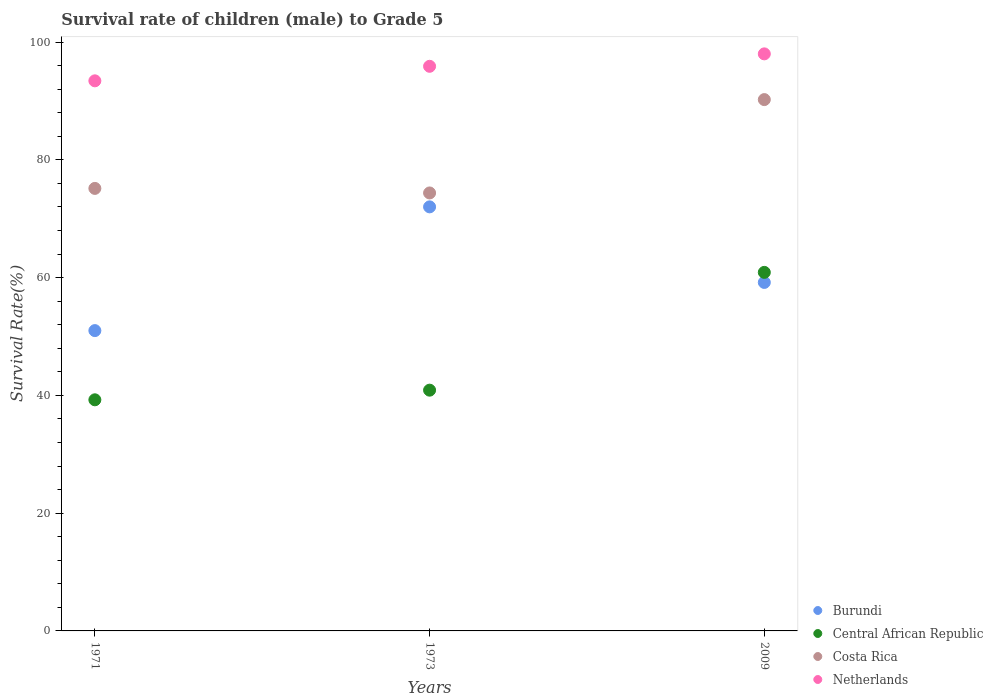How many different coloured dotlines are there?
Offer a very short reply. 4. Is the number of dotlines equal to the number of legend labels?
Offer a terse response. Yes. What is the survival rate of male children to grade 5 in Costa Rica in 1971?
Keep it short and to the point. 75.16. Across all years, what is the maximum survival rate of male children to grade 5 in Central African Republic?
Offer a very short reply. 60.9. Across all years, what is the minimum survival rate of male children to grade 5 in Central African Republic?
Ensure brevity in your answer.  39.25. In which year was the survival rate of male children to grade 5 in Central African Republic maximum?
Provide a short and direct response. 2009. In which year was the survival rate of male children to grade 5 in Central African Republic minimum?
Provide a succinct answer. 1971. What is the total survival rate of male children to grade 5 in Costa Rica in the graph?
Give a very brief answer. 239.78. What is the difference between the survival rate of male children to grade 5 in Costa Rica in 1971 and that in 1973?
Make the answer very short. 0.77. What is the difference between the survival rate of male children to grade 5 in Netherlands in 1971 and the survival rate of male children to grade 5 in Burundi in 2009?
Your response must be concise. 34.24. What is the average survival rate of male children to grade 5 in Netherlands per year?
Your response must be concise. 95.78. In the year 1973, what is the difference between the survival rate of male children to grade 5 in Netherlands and survival rate of male children to grade 5 in Costa Rica?
Offer a terse response. 21.51. What is the ratio of the survival rate of male children to grade 5 in Burundi in 1971 to that in 1973?
Provide a short and direct response. 0.71. Is the survival rate of male children to grade 5 in Costa Rica in 1973 less than that in 2009?
Your answer should be compact. Yes. Is the difference between the survival rate of male children to grade 5 in Netherlands in 1971 and 1973 greater than the difference between the survival rate of male children to grade 5 in Costa Rica in 1971 and 1973?
Provide a short and direct response. No. What is the difference between the highest and the second highest survival rate of male children to grade 5 in Costa Rica?
Provide a short and direct response. 15.08. What is the difference between the highest and the lowest survival rate of male children to grade 5 in Burundi?
Provide a succinct answer. 21.02. In how many years, is the survival rate of male children to grade 5 in Burundi greater than the average survival rate of male children to grade 5 in Burundi taken over all years?
Keep it short and to the point. 1. Is the sum of the survival rate of male children to grade 5 in Netherlands in 1971 and 2009 greater than the maximum survival rate of male children to grade 5 in Central African Republic across all years?
Offer a terse response. Yes. Does the survival rate of male children to grade 5 in Burundi monotonically increase over the years?
Give a very brief answer. No. Is the survival rate of male children to grade 5 in Burundi strictly greater than the survival rate of male children to grade 5 in Netherlands over the years?
Ensure brevity in your answer.  No. How many dotlines are there?
Offer a terse response. 4. What is the difference between two consecutive major ticks on the Y-axis?
Keep it short and to the point. 20. Does the graph contain any zero values?
Offer a very short reply. No. Where does the legend appear in the graph?
Offer a very short reply. Bottom right. How many legend labels are there?
Ensure brevity in your answer.  4. What is the title of the graph?
Your answer should be compact. Survival rate of children (male) to Grade 5. What is the label or title of the Y-axis?
Your answer should be very brief. Survival Rate(%). What is the Survival Rate(%) of Burundi in 1971?
Offer a terse response. 51.01. What is the Survival Rate(%) of Central African Republic in 1971?
Offer a terse response. 39.25. What is the Survival Rate(%) in Costa Rica in 1971?
Give a very brief answer. 75.16. What is the Survival Rate(%) in Netherlands in 1971?
Provide a short and direct response. 93.43. What is the Survival Rate(%) of Burundi in 1973?
Ensure brevity in your answer.  72.02. What is the Survival Rate(%) in Central African Republic in 1973?
Your answer should be compact. 40.89. What is the Survival Rate(%) in Costa Rica in 1973?
Your answer should be compact. 74.39. What is the Survival Rate(%) of Netherlands in 1973?
Your answer should be very brief. 95.9. What is the Survival Rate(%) of Burundi in 2009?
Offer a very short reply. 59.19. What is the Survival Rate(%) in Central African Republic in 2009?
Your response must be concise. 60.9. What is the Survival Rate(%) in Costa Rica in 2009?
Keep it short and to the point. 90.24. What is the Survival Rate(%) of Netherlands in 2009?
Your answer should be compact. 98.01. Across all years, what is the maximum Survival Rate(%) of Burundi?
Make the answer very short. 72.02. Across all years, what is the maximum Survival Rate(%) in Central African Republic?
Your response must be concise. 60.9. Across all years, what is the maximum Survival Rate(%) in Costa Rica?
Provide a short and direct response. 90.24. Across all years, what is the maximum Survival Rate(%) of Netherlands?
Offer a terse response. 98.01. Across all years, what is the minimum Survival Rate(%) in Burundi?
Your answer should be very brief. 51.01. Across all years, what is the minimum Survival Rate(%) in Central African Republic?
Offer a very short reply. 39.25. Across all years, what is the minimum Survival Rate(%) in Costa Rica?
Give a very brief answer. 74.39. Across all years, what is the minimum Survival Rate(%) in Netherlands?
Offer a terse response. 93.43. What is the total Survival Rate(%) in Burundi in the graph?
Offer a very short reply. 182.22. What is the total Survival Rate(%) of Central African Republic in the graph?
Offer a very short reply. 141.04. What is the total Survival Rate(%) in Costa Rica in the graph?
Your response must be concise. 239.78. What is the total Survival Rate(%) in Netherlands in the graph?
Your response must be concise. 287.33. What is the difference between the Survival Rate(%) of Burundi in 1971 and that in 1973?
Keep it short and to the point. -21.02. What is the difference between the Survival Rate(%) of Central African Republic in 1971 and that in 1973?
Provide a short and direct response. -1.64. What is the difference between the Survival Rate(%) of Costa Rica in 1971 and that in 1973?
Your response must be concise. 0.77. What is the difference between the Survival Rate(%) in Netherlands in 1971 and that in 1973?
Ensure brevity in your answer.  -2.47. What is the difference between the Survival Rate(%) of Burundi in 1971 and that in 2009?
Provide a short and direct response. -8.18. What is the difference between the Survival Rate(%) in Central African Republic in 1971 and that in 2009?
Give a very brief answer. -21.64. What is the difference between the Survival Rate(%) of Costa Rica in 1971 and that in 2009?
Ensure brevity in your answer.  -15.08. What is the difference between the Survival Rate(%) of Netherlands in 1971 and that in 2009?
Offer a terse response. -4.58. What is the difference between the Survival Rate(%) of Burundi in 1973 and that in 2009?
Your response must be concise. 12.84. What is the difference between the Survival Rate(%) of Central African Republic in 1973 and that in 2009?
Make the answer very short. -20.01. What is the difference between the Survival Rate(%) of Costa Rica in 1973 and that in 2009?
Make the answer very short. -15.86. What is the difference between the Survival Rate(%) of Netherlands in 1973 and that in 2009?
Offer a terse response. -2.11. What is the difference between the Survival Rate(%) of Burundi in 1971 and the Survival Rate(%) of Central African Republic in 1973?
Keep it short and to the point. 10.12. What is the difference between the Survival Rate(%) in Burundi in 1971 and the Survival Rate(%) in Costa Rica in 1973?
Your answer should be very brief. -23.38. What is the difference between the Survival Rate(%) of Burundi in 1971 and the Survival Rate(%) of Netherlands in 1973?
Make the answer very short. -44.89. What is the difference between the Survival Rate(%) of Central African Republic in 1971 and the Survival Rate(%) of Costa Rica in 1973?
Your answer should be compact. -35.13. What is the difference between the Survival Rate(%) in Central African Republic in 1971 and the Survival Rate(%) in Netherlands in 1973?
Give a very brief answer. -56.64. What is the difference between the Survival Rate(%) in Costa Rica in 1971 and the Survival Rate(%) in Netherlands in 1973?
Your answer should be compact. -20.74. What is the difference between the Survival Rate(%) of Burundi in 1971 and the Survival Rate(%) of Central African Republic in 2009?
Provide a short and direct response. -9.89. What is the difference between the Survival Rate(%) in Burundi in 1971 and the Survival Rate(%) in Costa Rica in 2009?
Your response must be concise. -39.24. What is the difference between the Survival Rate(%) of Burundi in 1971 and the Survival Rate(%) of Netherlands in 2009?
Your answer should be very brief. -47. What is the difference between the Survival Rate(%) of Central African Republic in 1971 and the Survival Rate(%) of Costa Rica in 2009?
Provide a short and direct response. -50.99. What is the difference between the Survival Rate(%) of Central African Republic in 1971 and the Survival Rate(%) of Netherlands in 2009?
Give a very brief answer. -58.75. What is the difference between the Survival Rate(%) in Costa Rica in 1971 and the Survival Rate(%) in Netherlands in 2009?
Your answer should be very brief. -22.85. What is the difference between the Survival Rate(%) of Burundi in 1973 and the Survival Rate(%) of Central African Republic in 2009?
Make the answer very short. 11.13. What is the difference between the Survival Rate(%) in Burundi in 1973 and the Survival Rate(%) in Costa Rica in 2009?
Provide a succinct answer. -18.22. What is the difference between the Survival Rate(%) in Burundi in 1973 and the Survival Rate(%) in Netherlands in 2009?
Make the answer very short. -25.98. What is the difference between the Survival Rate(%) in Central African Republic in 1973 and the Survival Rate(%) in Costa Rica in 2009?
Offer a very short reply. -49.35. What is the difference between the Survival Rate(%) in Central African Republic in 1973 and the Survival Rate(%) in Netherlands in 2009?
Provide a short and direct response. -57.12. What is the difference between the Survival Rate(%) of Costa Rica in 1973 and the Survival Rate(%) of Netherlands in 2009?
Keep it short and to the point. -23.62. What is the average Survival Rate(%) in Burundi per year?
Your response must be concise. 60.74. What is the average Survival Rate(%) in Central African Republic per year?
Ensure brevity in your answer.  47.01. What is the average Survival Rate(%) of Costa Rica per year?
Keep it short and to the point. 79.93. What is the average Survival Rate(%) of Netherlands per year?
Offer a terse response. 95.78. In the year 1971, what is the difference between the Survival Rate(%) of Burundi and Survival Rate(%) of Central African Republic?
Your answer should be compact. 11.75. In the year 1971, what is the difference between the Survival Rate(%) in Burundi and Survival Rate(%) in Costa Rica?
Provide a short and direct response. -24.15. In the year 1971, what is the difference between the Survival Rate(%) of Burundi and Survival Rate(%) of Netherlands?
Provide a short and direct response. -42.42. In the year 1971, what is the difference between the Survival Rate(%) in Central African Republic and Survival Rate(%) in Costa Rica?
Keep it short and to the point. -35.9. In the year 1971, what is the difference between the Survival Rate(%) of Central African Republic and Survival Rate(%) of Netherlands?
Give a very brief answer. -54.18. In the year 1971, what is the difference between the Survival Rate(%) in Costa Rica and Survival Rate(%) in Netherlands?
Provide a succinct answer. -18.27. In the year 1973, what is the difference between the Survival Rate(%) of Burundi and Survival Rate(%) of Central African Republic?
Ensure brevity in your answer.  31.13. In the year 1973, what is the difference between the Survival Rate(%) of Burundi and Survival Rate(%) of Costa Rica?
Offer a terse response. -2.36. In the year 1973, what is the difference between the Survival Rate(%) of Burundi and Survival Rate(%) of Netherlands?
Offer a terse response. -23.87. In the year 1973, what is the difference between the Survival Rate(%) of Central African Republic and Survival Rate(%) of Costa Rica?
Provide a succinct answer. -33.5. In the year 1973, what is the difference between the Survival Rate(%) in Central African Republic and Survival Rate(%) in Netherlands?
Your response must be concise. -55.01. In the year 1973, what is the difference between the Survival Rate(%) of Costa Rica and Survival Rate(%) of Netherlands?
Your answer should be very brief. -21.51. In the year 2009, what is the difference between the Survival Rate(%) of Burundi and Survival Rate(%) of Central African Republic?
Offer a very short reply. -1.71. In the year 2009, what is the difference between the Survival Rate(%) of Burundi and Survival Rate(%) of Costa Rica?
Ensure brevity in your answer.  -31.05. In the year 2009, what is the difference between the Survival Rate(%) of Burundi and Survival Rate(%) of Netherlands?
Make the answer very short. -38.82. In the year 2009, what is the difference between the Survival Rate(%) of Central African Republic and Survival Rate(%) of Costa Rica?
Offer a very short reply. -29.35. In the year 2009, what is the difference between the Survival Rate(%) in Central African Republic and Survival Rate(%) in Netherlands?
Offer a terse response. -37.11. In the year 2009, what is the difference between the Survival Rate(%) in Costa Rica and Survival Rate(%) in Netherlands?
Make the answer very short. -7.77. What is the ratio of the Survival Rate(%) of Burundi in 1971 to that in 1973?
Make the answer very short. 0.71. What is the ratio of the Survival Rate(%) of Central African Republic in 1971 to that in 1973?
Offer a terse response. 0.96. What is the ratio of the Survival Rate(%) of Costa Rica in 1971 to that in 1973?
Your answer should be compact. 1.01. What is the ratio of the Survival Rate(%) in Netherlands in 1971 to that in 1973?
Your answer should be compact. 0.97. What is the ratio of the Survival Rate(%) in Burundi in 1971 to that in 2009?
Make the answer very short. 0.86. What is the ratio of the Survival Rate(%) in Central African Republic in 1971 to that in 2009?
Make the answer very short. 0.64. What is the ratio of the Survival Rate(%) in Costa Rica in 1971 to that in 2009?
Provide a short and direct response. 0.83. What is the ratio of the Survival Rate(%) in Netherlands in 1971 to that in 2009?
Give a very brief answer. 0.95. What is the ratio of the Survival Rate(%) in Burundi in 1973 to that in 2009?
Offer a very short reply. 1.22. What is the ratio of the Survival Rate(%) of Central African Republic in 1973 to that in 2009?
Your response must be concise. 0.67. What is the ratio of the Survival Rate(%) in Costa Rica in 1973 to that in 2009?
Your answer should be very brief. 0.82. What is the ratio of the Survival Rate(%) in Netherlands in 1973 to that in 2009?
Offer a very short reply. 0.98. What is the difference between the highest and the second highest Survival Rate(%) of Burundi?
Ensure brevity in your answer.  12.84. What is the difference between the highest and the second highest Survival Rate(%) in Central African Republic?
Keep it short and to the point. 20.01. What is the difference between the highest and the second highest Survival Rate(%) of Costa Rica?
Offer a very short reply. 15.08. What is the difference between the highest and the second highest Survival Rate(%) of Netherlands?
Give a very brief answer. 2.11. What is the difference between the highest and the lowest Survival Rate(%) of Burundi?
Offer a very short reply. 21.02. What is the difference between the highest and the lowest Survival Rate(%) in Central African Republic?
Keep it short and to the point. 21.64. What is the difference between the highest and the lowest Survival Rate(%) in Costa Rica?
Give a very brief answer. 15.86. What is the difference between the highest and the lowest Survival Rate(%) in Netherlands?
Offer a very short reply. 4.58. 